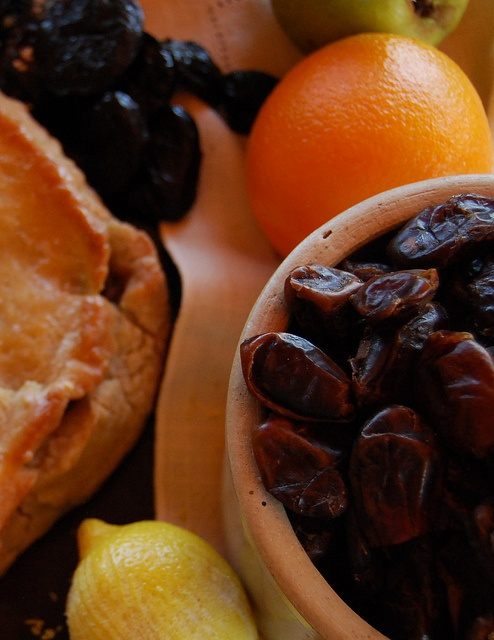Describe the objects in this image and their specific colors. I can see orange in black, brown, red, and orange tones, bowl in black, brown, and maroon tones, and apple in black, maroon, and olive tones in this image. 